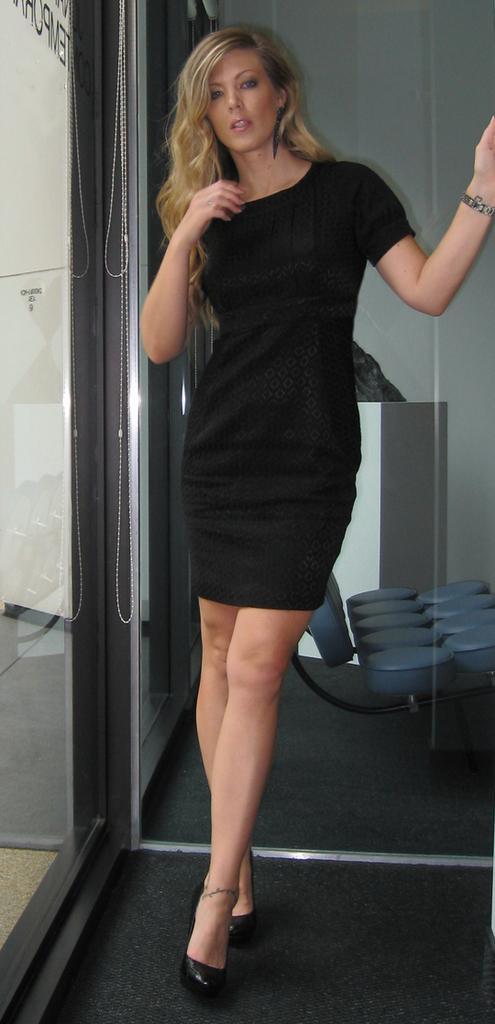Can you describe this image briefly? In this image there is a woman with black color frock standing in the carpet i,n the back ground there is chair, board or cupboard , door. 